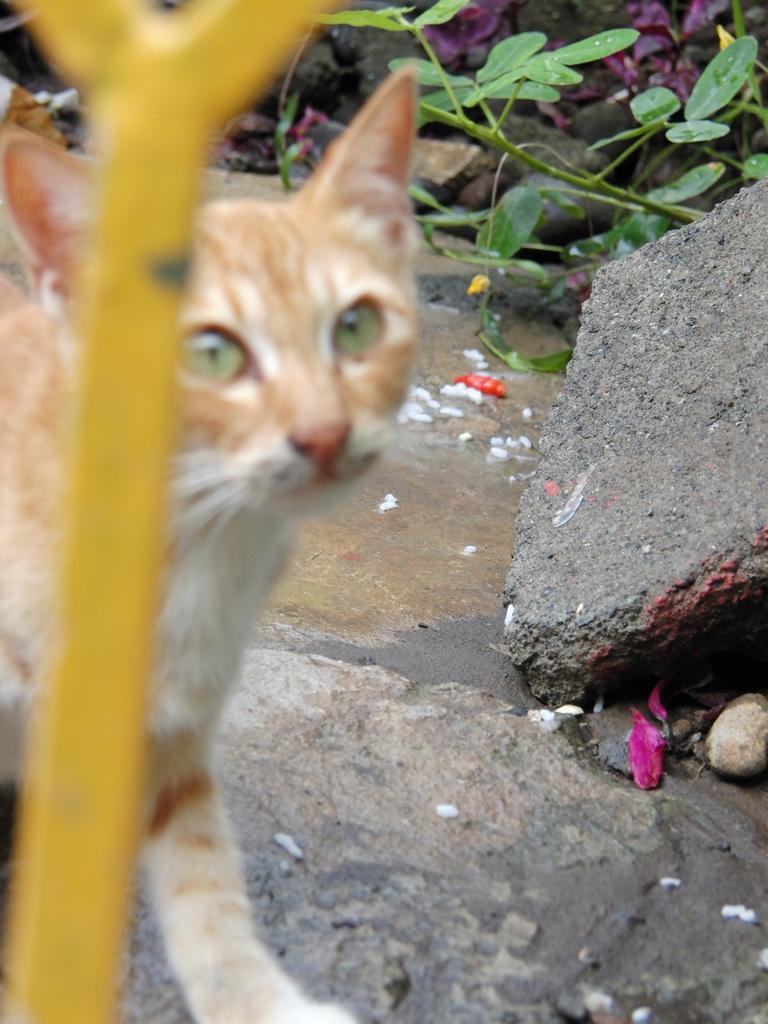Can you describe this image briefly? In this picture there is a cat which is standing on the stone. Here we can see some flowers and leaves. On the left there is a pipe. 